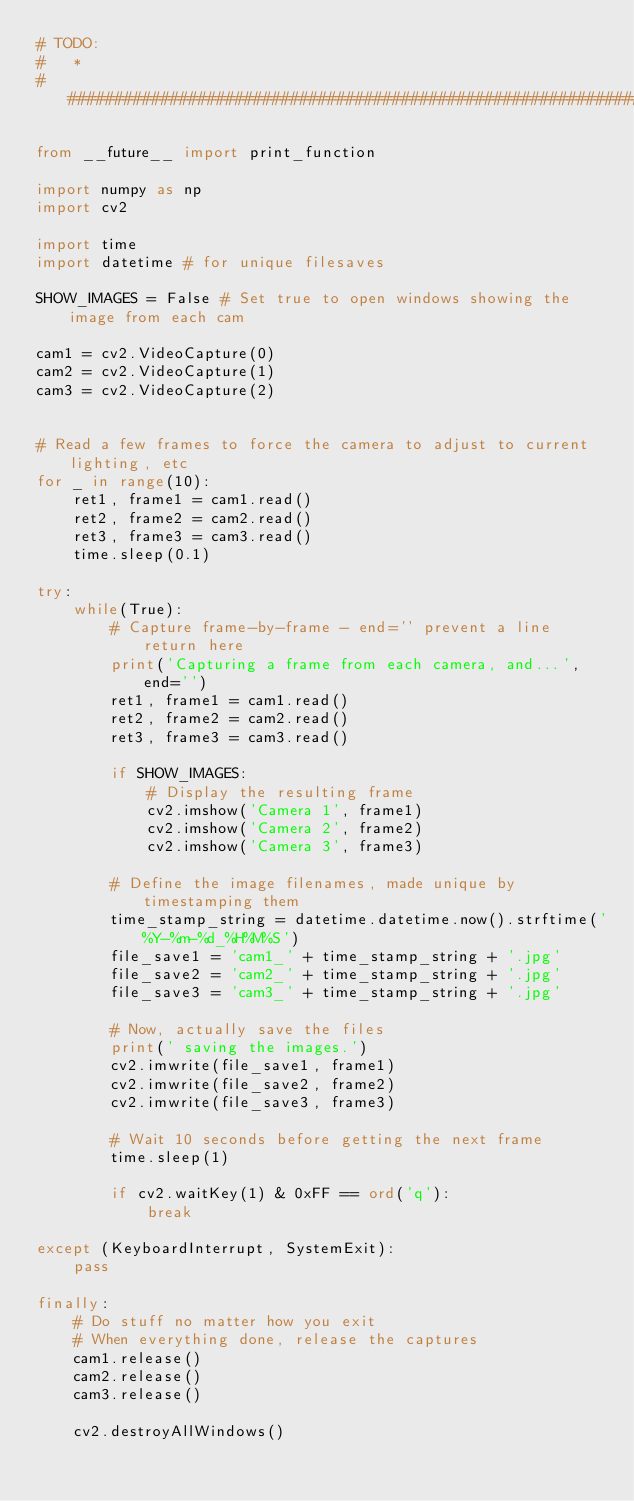<code> <loc_0><loc_0><loc_500><loc_500><_Python_># TODO:
#   * 
###############################################################################

from __future__ import print_function

import numpy as np
import cv2

import time
import datetime # for unique filesaves

SHOW_IMAGES = False # Set true to open windows showing the image from each cam

cam1 = cv2.VideoCapture(0)
cam2 = cv2.VideoCapture(1)
cam3 = cv2.VideoCapture(2)


# Read a few frames to force the camera to adjust to current lighting, etc
for _ in range(10):
    ret1, frame1 = cam1.read()
    ret2, frame2 = cam2.read()
    ret3, frame3 = cam3.read()
    time.sleep(0.1)

try:
    while(True):
        # Capture frame-by-frame - end='' prevent a line return here
        print('Capturing a frame from each camera, and...', end='')
        ret1, frame1 = cam1.read()
        ret2, frame2 = cam2.read()
        ret3, frame3 = cam3.read()

        if SHOW_IMAGES: 
            # Display the resulting frame
            cv2.imshow('Camera 1', frame1)
            cv2.imshow('Camera 2', frame2)
            cv2.imshow('Camera 3', frame3)
        
        # Define the image filenames, made unique by timestamping them
        time_stamp_string = datetime.datetime.now().strftime('%Y-%m-%d_%H%M%S')
        file_save1 = 'cam1_' + time_stamp_string + '.jpg'
        file_save2 = 'cam2_' + time_stamp_string + '.jpg'
        file_save3 = 'cam3_' + time_stamp_string + '.jpg'
        
        # Now, actually save the files
        print(' saving the images.')
        cv2.imwrite(file_save1, frame1)
        cv2.imwrite(file_save2, frame2)
        cv2.imwrite(file_save3, frame3)
        
        # Wait 10 seconds before getting the next frame
        time.sleep(1)

        if cv2.waitKey(1) & 0xFF == ord('q'):
            break

except (KeyboardInterrupt, SystemExit):
    pass

finally:
    # Do stuff no matter how you exit
    # When everything done, release the captures
    cam1.release()
    cam2.release()
    cam3.release()

    cv2.destroyAllWindows()</code> 